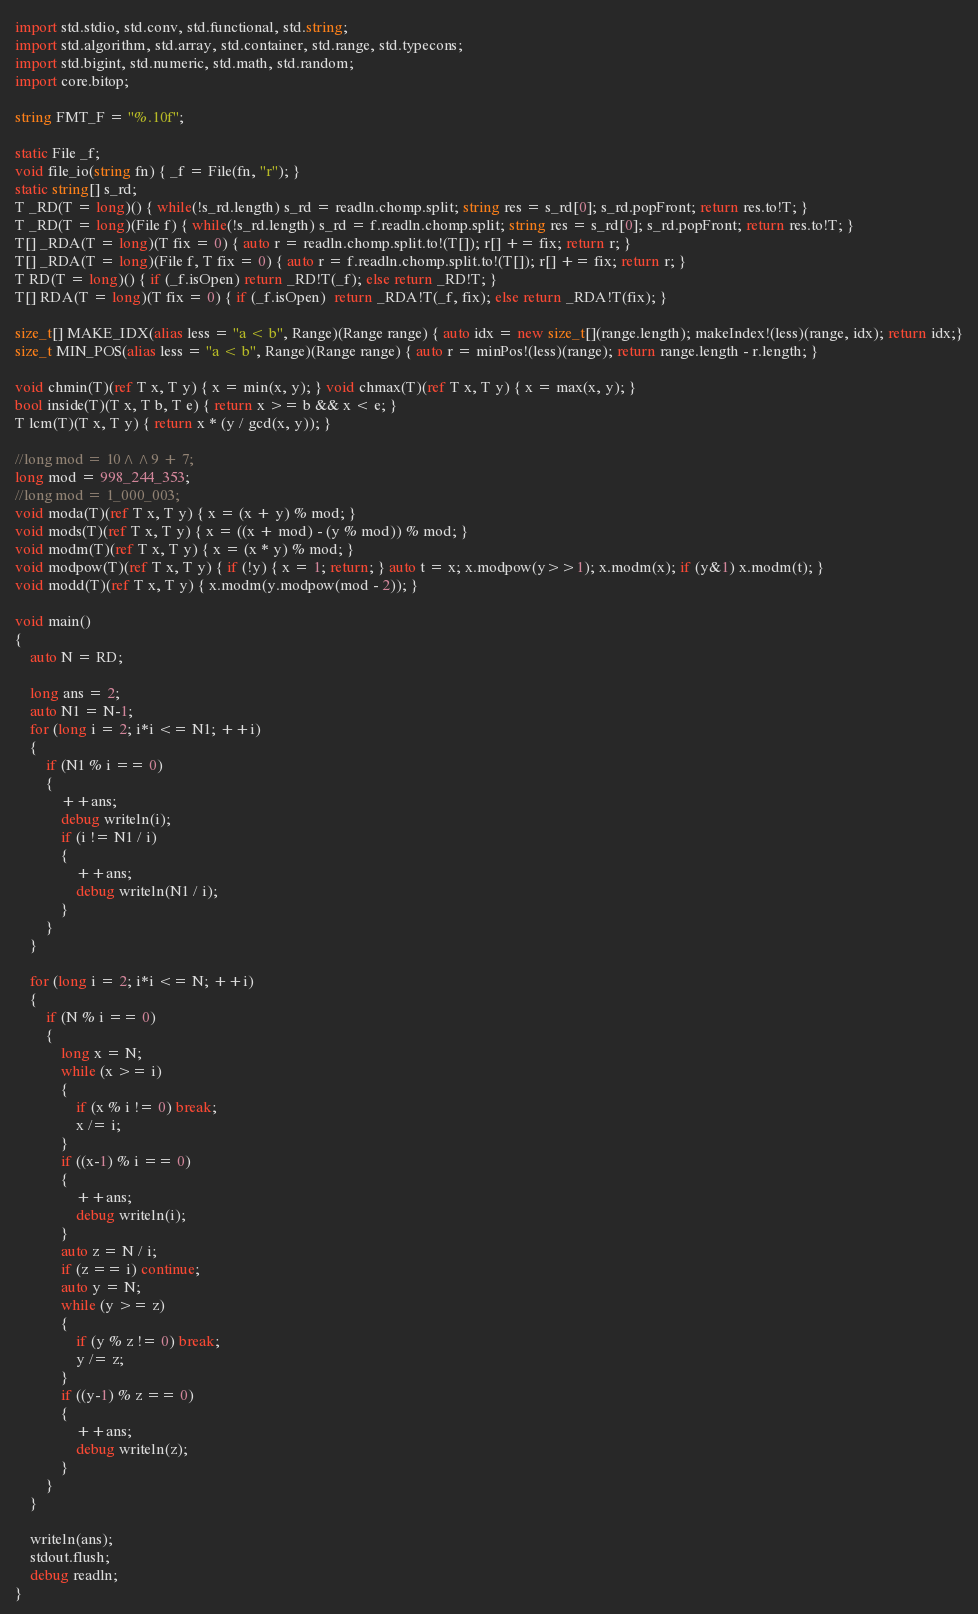Convert code to text. <code><loc_0><loc_0><loc_500><loc_500><_D_>import std.stdio, std.conv, std.functional, std.string;
import std.algorithm, std.array, std.container, std.range, std.typecons;
import std.bigint, std.numeric, std.math, std.random;
import core.bitop;

string FMT_F = "%.10f";

static File _f;
void file_io(string fn) { _f = File(fn, "r"); }
static string[] s_rd;
T _RD(T = long)() { while(!s_rd.length) s_rd = readln.chomp.split; string res = s_rd[0]; s_rd.popFront; return res.to!T; }
T _RD(T = long)(File f) { while(!s_rd.length) s_rd = f.readln.chomp.split; string res = s_rd[0]; s_rd.popFront; return res.to!T; }
T[] _RDA(T = long)(T fix = 0) { auto r = readln.chomp.split.to!(T[]); r[] += fix; return r; }
T[] _RDA(T = long)(File f, T fix = 0) { auto r = f.readln.chomp.split.to!(T[]); r[] += fix; return r; }
T RD(T = long)() { if (_f.isOpen) return _RD!T(_f); else return _RD!T; }
T[] RDA(T = long)(T fix = 0) { if (_f.isOpen)  return _RDA!T(_f, fix); else return _RDA!T(fix); }

size_t[] MAKE_IDX(alias less = "a < b", Range)(Range range) { auto idx = new size_t[](range.length); makeIndex!(less)(range, idx); return idx;}
size_t MIN_POS(alias less = "a < b", Range)(Range range) { auto r = minPos!(less)(range); return range.length - r.length; }

void chmin(T)(ref T x, T y) { x = min(x, y); } void chmax(T)(ref T x, T y) { x = max(x, y); }
bool inside(T)(T x, T b, T e) { return x >= b && x < e; }
T lcm(T)(T x, T y) { return x * (y / gcd(x, y)); }

//long mod = 10^^9 + 7;
long mod = 998_244_353;
//long mod = 1_000_003;
void moda(T)(ref T x, T y) { x = (x + y) % mod; }
void mods(T)(ref T x, T y) { x = ((x + mod) - (y % mod)) % mod; }
void modm(T)(ref T x, T y) { x = (x * y) % mod; }
void modpow(T)(ref T x, T y) { if (!y) { x = 1; return; } auto t = x; x.modpow(y>>1); x.modm(x); if (y&1) x.modm(t); }
void modd(T)(ref T x, T y) { x.modm(y.modpow(mod - 2)); }

void main()
{
	auto N = RD;

	long ans = 2;
	auto N1 = N-1;
	for (long i = 2; i*i <= N1; ++i)
	{
		if (N1 % i == 0)
		{
			++ans;
			debug writeln(i);
			if (i != N1 / i)
			{
				++ans;
				debug writeln(N1 / i);
			}
		}
	}

	for (long i = 2; i*i <= N; ++i)
	{
		if (N % i == 0)
		{
			long x = N;
			while (x >= i)
			{
				if (x % i != 0) break;
				x /= i;
			}
			if ((x-1) % i == 0)
			{
				++ans;
				debug writeln(i);
			}
			auto z = N / i;
			if (z == i) continue;
			auto y = N;
			while (y >= z)
			{
				if (y % z != 0) break;
				y /= z;
			}
			if ((y-1) % z == 0)
			{
				++ans;
				debug writeln(z);
			}
		}
	}

	writeln(ans);
	stdout.flush;
	debug readln;
}
</code> 